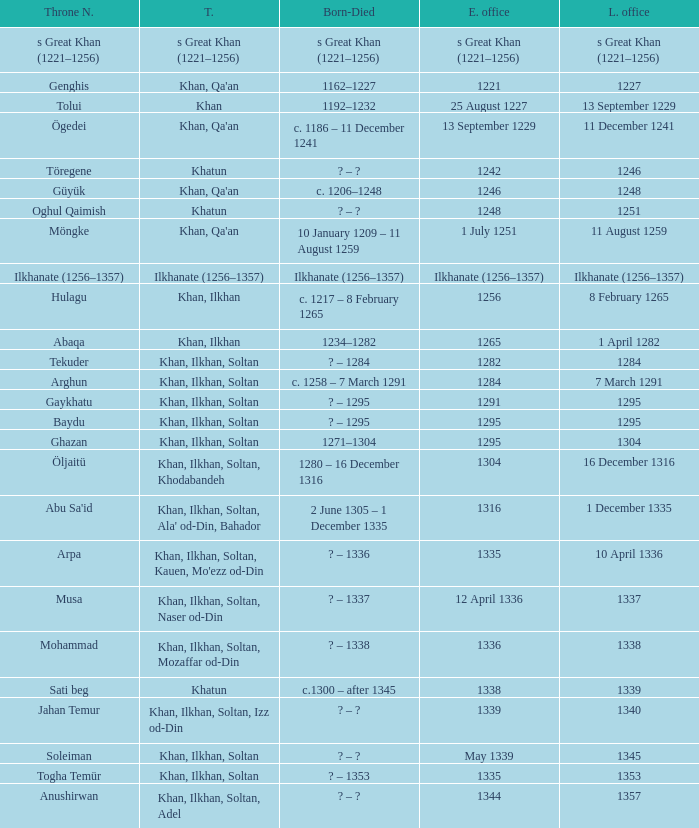What is the entered office that has 1337 as the left office? 12 April 1336. I'm looking to parse the entire table for insights. Could you assist me with that? {'header': ['Throne N.', 'T.', 'Born-Died', 'E. office', 'L. office'], 'rows': [['s Great Khan (1221–1256)', 's Great Khan (1221–1256)', 's Great Khan (1221–1256)', 's Great Khan (1221–1256)', 's Great Khan (1221–1256)'], ['Genghis', "Khan, Qa'an", '1162–1227', '1221', '1227'], ['Tolui', 'Khan', '1192–1232', '25 August 1227', '13 September 1229'], ['Ögedei', "Khan, Qa'an", 'c. 1186 – 11 December 1241', '13 September 1229', '11 December 1241'], ['Töregene', 'Khatun', '? – ?', '1242', '1246'], ['Güyük', "Khan, Qa'an", 'c. 1206–1248', '1246', '1248'], ['Oghul Qaimish', 'Khatun', '? – ?', '1248', '1251'], ['Möngke', "Khan, Qa'an", '10 January 1209 – 11 August 1259', '1 July 1251', '11 August 1259'], ['Ilkhanate (1256–1357)', 'Ilkhanate (1256–1357)', 'Ilkhanate (1256–1357)', 'Ilkhanate (1256–1357)', 'Ilkhanate (1256–1357)'], ['Hulagu', 'Khan, Ilkhan', 'c. 1217 – 8 February 1265', '1256', '8 February 1265'], ['Abaqa', 'Khan, Ilkhan', '1234–1282', '1265', '1 April 1282'], ['Tekuder', 'Khan, Ilkhan, Soltan', '? – 1284', '1282', '1284'], ['Arghun', 'Khan, Ilkhan, Soltan', 'c. 1258 – 7 March 1291', '1284', '7 March 1291'], ['Gaykhatu', 'Khan, Ilkhan, Soltan', '? – 1295', '1291', '1295'], ['Baydu', 'Khan, Ilkhan, Soltan', '? – 1295', '1295', '1295'], ['Ghazan', 'Khan, Ilkhan, Soltan', '1271–1304', '1295', '1304'], ['Öljaitü', 'Khan, Ilkhan, Soltan, Khodabandeh', '1280 – 16 December 1316', '1304', '16 December 1316'], ["Abu Sa'id", "Khan, Ilkhan, Soltan, Ala' od-Din, Bahador", '2 June 1305 – 1 December 1335', '1316', '1 December 1335'], ['Arpa', "Khan, Ilkhan, Soltan, Kauen, Mo'ezz od-Din", '? – 1336', '1335', '10 April 1336'], ['Musa', 'Khan, Ilkhan, Soltan, Naser od-Din', '? – 1337', '12 April 1336', '1337'], ['Mohammad', 'Khan, Ilkhan, Soltan, Mozaffar od-Din', '? – 1338', '1336', '1338'], ['Sati beg', 'Khatun', 'c.1300 – after 1345', '1338', '1339'], ['Jahan Temur', 'Khan, Ilkhan, Soltan, Izz od-Din', '? – ?', '1339', '1340'], ['Soleiman', 'Khan, Ilkhan, Soltan', '? – ?', 'May 1339', '1345'], ['Togha Temür', 'Khan, Ilkhan, Soltan', '? – 1353', '1335', '1353'], ['Anushirwan', 'Khan, Ilkhan, Soltan, Adel', '? – ?', '1344', '1357']]} 